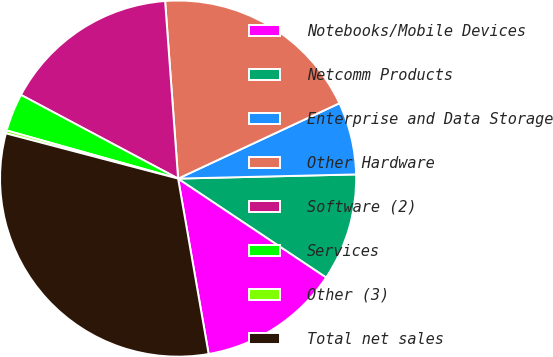<chart> <loc_0><loc_0><loc_500><loc_500><pie_chart><fcel>Notebooks/Mobile Devices<fcel>Netcomm Products<fcel>Enterprise and Data Storage<fcel>Other Hardware<fcel>Software (2)<fcel>Services<fcel>Other (3)<fcel>Total net sales<nl><fcel>12.89%<fcel>9.74%<fcel>6.58%<fcel>19.21%<fcel>16.05%<fcel>3.43%<fcel>0.27%<fcel>31.83%<nl></chart> 